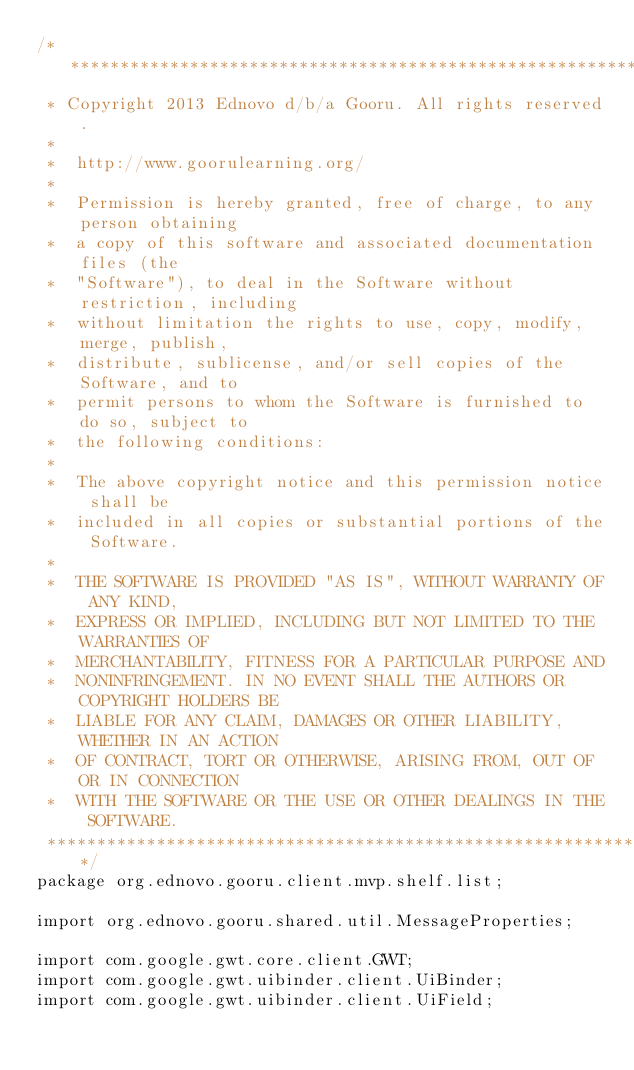<code> <loc_0><loc_0><loc_500><loc_500><_Java_>/*******************************************************************************
 * Copyright 2013 Ednovo d/b/a Gooru. All rights reserved.
 * 
 *  http://www.goorulearning.org/
 * 
 *  Permission is hereby granted, free of charge, to any person obtaining
 *  a copy of this software and associated documentation files (the
 *  "Software"), to deal in the Software without restriction, including
 *  without limitation the rights to use, copy, modify, merge, publish,
 *  distribute, sublicense, and/or sell copies of the Software, and to
 *  permit persons to whom the Software is furnished to do so, subject to
 *  the following conditions:
 * 
 *  The above copyright notice and this permission notice shall be
 *  included in all copies or substantial portions of the Software.
 * 
 *  THE SOFTWARE IS PROVIDED "AS IS", WITHOUT WARRANTY OF ANY KIND,
 *  EXPRESS OR IMPLIED, INCLUDING BUT NOT LIMITED TO THE WARRANTIES OF
 *  MERCHANTABILITY, FITNESS FOR A PARTICULAR PURPOSE AND
 *  NONINFRINGEMENT. IN NO EVENT SHALL THE AUTHORS OR COPYRIGHT HOLDERS BE
 *  LIABLE FOR ANY CLAIM, DAMAGES OR OTHER LIABILITY, WHETHER IN AN ACTION
 *  OF CONTRACT, TORT OR OTHERWISE, ARISING FROM, OUT OF OR IN CONNECTION
 *  WITH THE SOFTWARE OR THE USE OR OTHER DEALINGS IN THE SOFTWARE.
 ******************************************************************************/
package org.ednovo.gooru.client.mvp.shelf.list;

import org.ednovo.gooru.shared.util.MessageProperties;

import com.google.gwt.core.client.GWT;
import com.google.gwt.uibinder.client.UiBinder;
import com.google.gwt.uibinder.client.UiField;</code> 